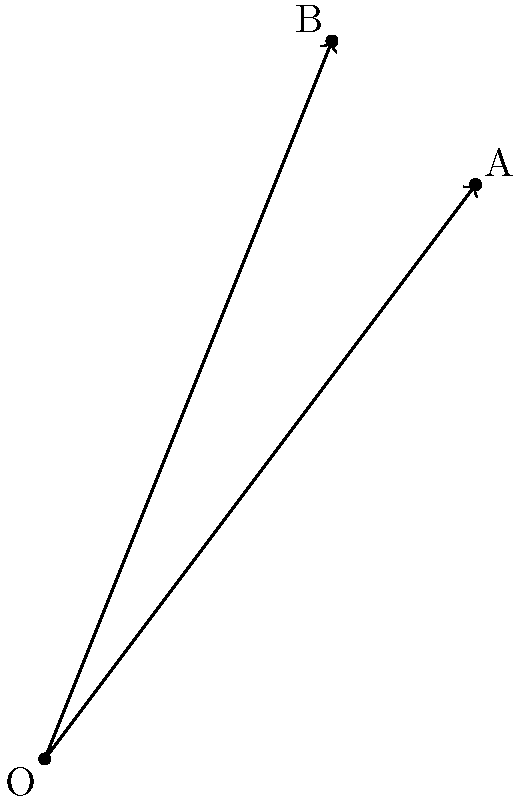In the coordinate plane above, vectors $\vec{a}$ and $\vec{b}$ are represented by arrows from the origin O to points A(3,4) and B(2,5) respectively. As a songwriter, imagine these vectors represent two melodic patterns in your composition. Calculate the angle between these vectors, which could symbolize the harmonic relationship between the melodies. Express your answer in degrees, rounded to the nearest whole number. To find the angle between two vectors, we can use the dot product formula:

$$\cos \theta = \frac{\vec{a} \cdot \vec{b}}{|\vec{a}||\vec{b}|}$$

Step 1: Calculate the dot product $\vec{a} \cdot \vec{b}$
$\vec{a} \cdot \vec{b} = (3)(2) + (4)(5) = 6 + 20 = 26$

Step 2: Calculate the magnitudes of the vectors
$|\vec{a}| = \sqrt{3^2 + 4^2} = \sqrt{9 + 16} = \sqrt{25} = 5$
$|\vec{b}| = \sqrt{2^2 + 5^2} = \sqrt{4 + 25} = \sqrt{29}$

Step 3: Apply the dot product formula
$$\cos \theta = \frac{26}{5\sqrt{29}}$$

Step 4: Take the inverse cosine (arccos) of both sides
$$\theta = \arccos(\frac{26}{5\sqrt{29}})$$

Step 5: Calculate and convert to degrees
$$\theta \approx 0.2492 \text{ radians} \approx 14.28°$$

Step 6: Round to the nearest whole number
$$\theta \approx 14°$$
Answer: 14° 